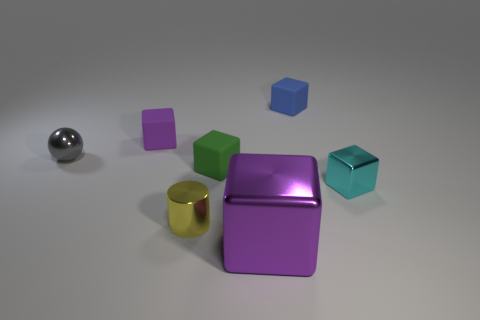Subtract all blue blocks. How many blocks are left? 4 Subtract all green cubes. Subtract all gray spheres. How many cubes are left? 4 Add 2 blue metallic blocks. How many objects exist? 9 Subtract all blocks. How many objects are left? 2 Add 4 green objects. How many green objects are left? 5 Add 3 cyan rubber cubes. How many cyan rubber cubes exist? 3 Subtract 0 cyan cylinders. How many objects are left? 7 Subtract all purple objects. Subtract all small yellow matte cylinders. How many objects are left? 5 